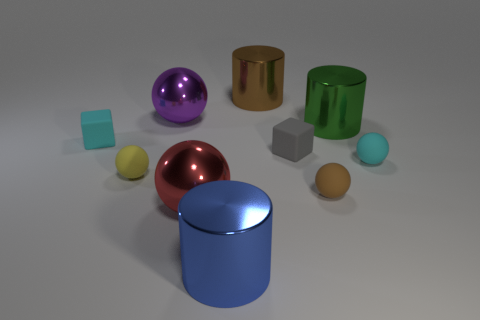Are there any patterns or designs on any of the objects? No discernible patterns or intricate designs are visible on the objects. Each item presents a solid color with a plain surface, which can be indicative of a simplified or minimalist aesthetic. 